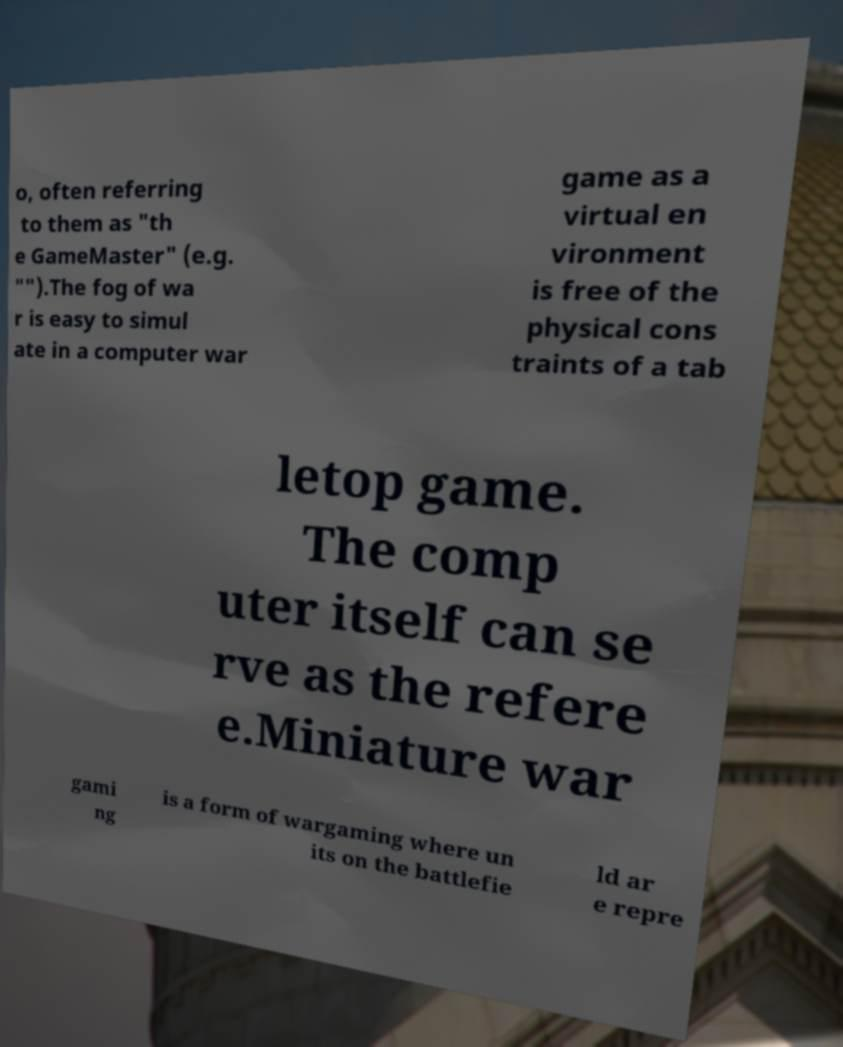Can you read and provide the text displayed in the image?This photo seems to have some interesting text. Can you extract and type it out for me? o, often referring to them as "th e GameMaster" (e.g. "").The fog of wa r is easy to simul ate in a computer war game as a virtual en vironment is free of the physical cons traints of a tab letop game. The comp uter itself can se rve as the refere e.Miniature war gami ng is a form of wargaming where un its on the battlefie ld ar e repre 